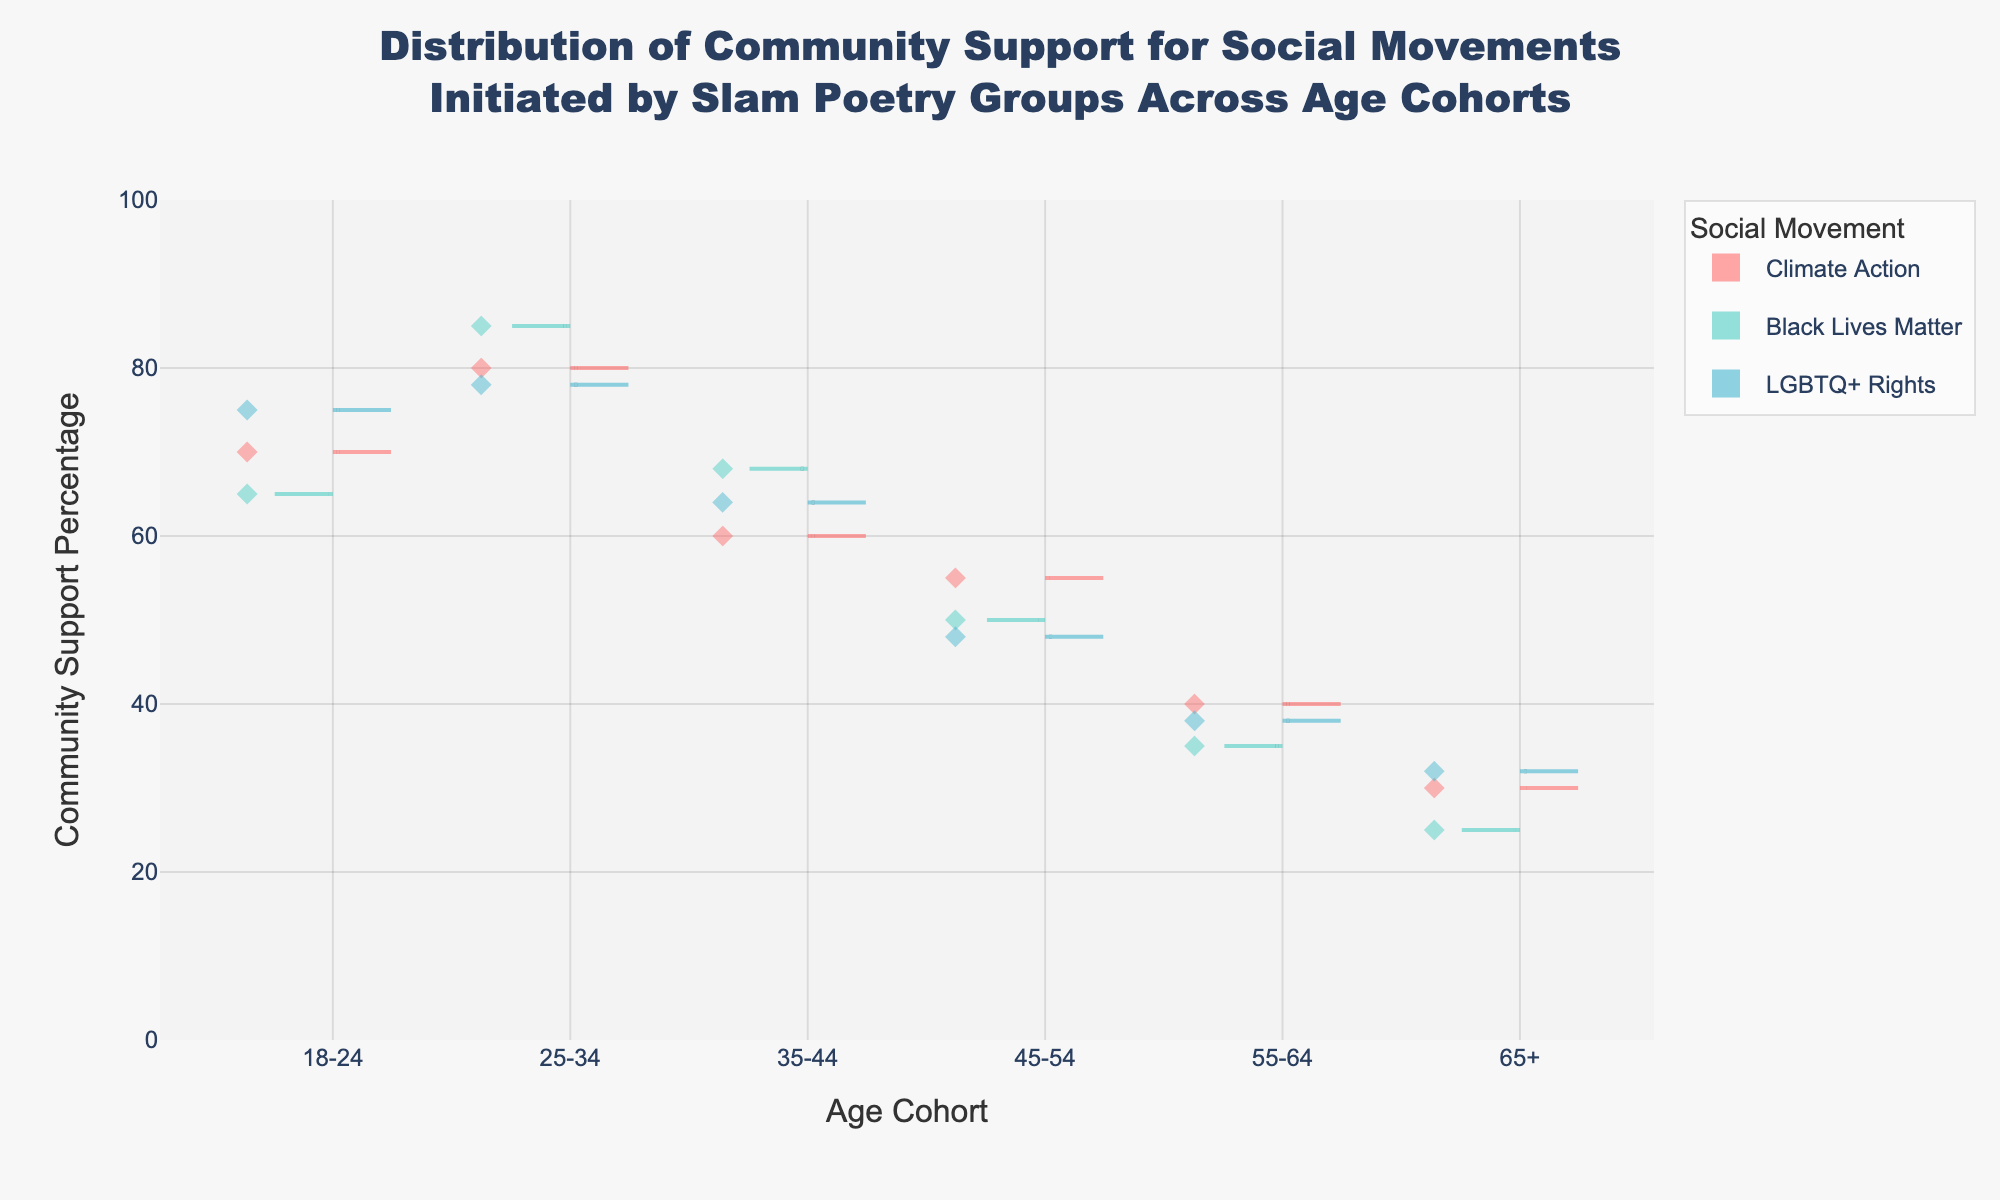What's the title of the figure? Refer to the text at the top center of the figure.
Answer: Distribution of Community Support for Social Movements Initiated by Slam Poetry Groups Across Age Cohorts How are the age cohorts displayed on the x-axis? The x-axis ticks represent different age cohorts. They are "18-24", "25-34", "35-44", "45-54", "55-64", and "65+".
Answer: They are displayed as categories from "18-24" to "65+" in ascending order Which social movement shows the highest community support percentage in the 25-34 age cohort? Identify the highest point within the 25-34 age cohort and correlate it with the legend for the color representing the social movement.
Answer: Black Lives Matter What is the range of community support percentages for the “Climate Action” movement across all age cohorts? Examine the span of the violin plots associated with "Climate Action" across all age cohorts.
Answer: 30% to 80% Which age cohort shows the lowest community support for the Black Lives Matter movement? Observe the lowest value on the y-axis within the violin plots for "Black Lives Matter" and cross-reference with the corresponding age cohort on the x-axis.
Answer: 65+ Between which two age cohorts does the community support for Urban Rhythms show the largest drop? Compare the endpoints of the violin plots representing Urban Rhythms across all age cohorts and identify the largest difference.
Answer: 35-44 and 45-54 Which social movement has more consistent support across age cohorts, indicated by a narrower spread in the violin plot? Compare the spreads (widths) of the violin plots for each social movement across all age cohorts.
Answer: LGBTQ+ Rights What's the average community support percentage for Street Poets in the 18-24 and 25-34 age cohorts? Find the support percentages for Street Poets in both age cohorts and calculate the average. (75 + 78) / 2 = 76.5
Answer: 76.5 How does community support for Black Lives Matter compare between the youngest (18-24) and oldest (65+) age cohorts? Look at the y-axis values for Black Lives Matter in the 18-24 and 65+ age cohorts and compare them.
Answer: Significantly higher in the 18-24 cohort What does the presence of jittered points within the violins signify? Refer to the nature of points within the violin plots, which typically represent individual data points.
Answer: Individual data points within the distribution 